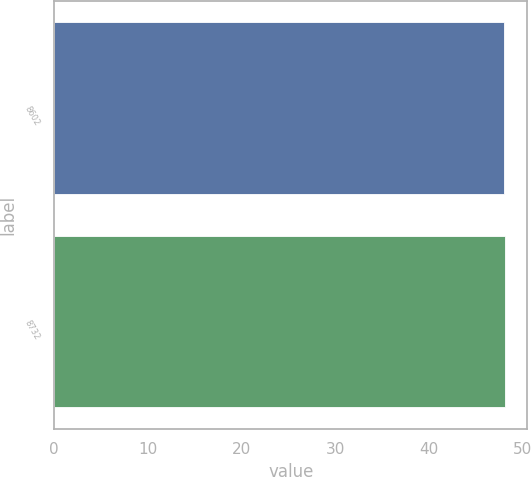<chart> <loc_0><loc_0><loc_500><loc_500><bar_chart><fcel>8602<fcel>8732<nl><fcel>48.04<fcel>48.14<nl></chart> 